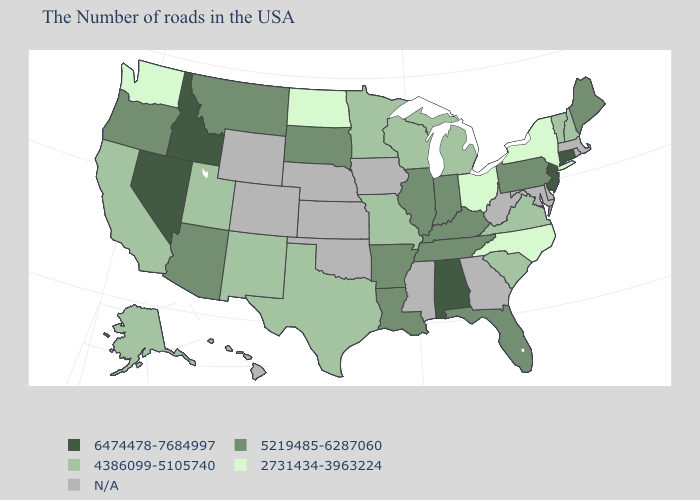What is the value of Pennsylvania?
Be succinct. 5219485-6287060. Does the first symbol in the legend represent the smallest category?
Answer briefly. No. What is the highest value in the South ?
Give a very brief answer. 6474478-7684997. Which states have the highest value in the USA?
Be succinct. Connecticut, New Jersey, Alabama, Idaho, Nevada. Name the states that have a value in the range 6474478-7684997?
Give a very brief answer. Connecticut, New Jersey, Alabama, Idaho, Nevada. What is the value of Oklahoma?
Short answer required. N/A. What is the value of North Carolina?
Be succinct. 2731434-3963224. Which states have the lowest value in the MidWest?
Give a very brief answer. Ohio, North Dakota. What is the lowest value in the USA?
Answer briefly. 2731434-3963224. What is the value of New Mexico?
Concise answer only. 4386099-5105740. Which states have the highest value in the USA?
Concise answer only. Connecticut, New Jersey, Alabama, Idaho, Nevada. Does the map have missing data?
Short answer required. Yes. Which states have the highest value in the USA?
Answer briefly. Connecticut, New Jersey, Alabama, Idaho, Nevada. Does South Dakota have the highest value in the MidWest?
Answer briefly. Yes. 